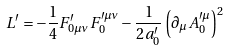<formula> <loc_0><loc_0><loc_500><loc_500>L ^ { \prime } = - \frac { 1 } { 4 } F ^ { \prime } _ { 0 \mu \nu } F _ { 0 } ^ { \prime \mu \nu } - \frac { 1 } { 2 a ^ { \prime } _ { 0 } } \left ( \partial _ { \mu } A _ { 0 } ^ { \prime \mu } \right ) ^ { 2 }</formula> 